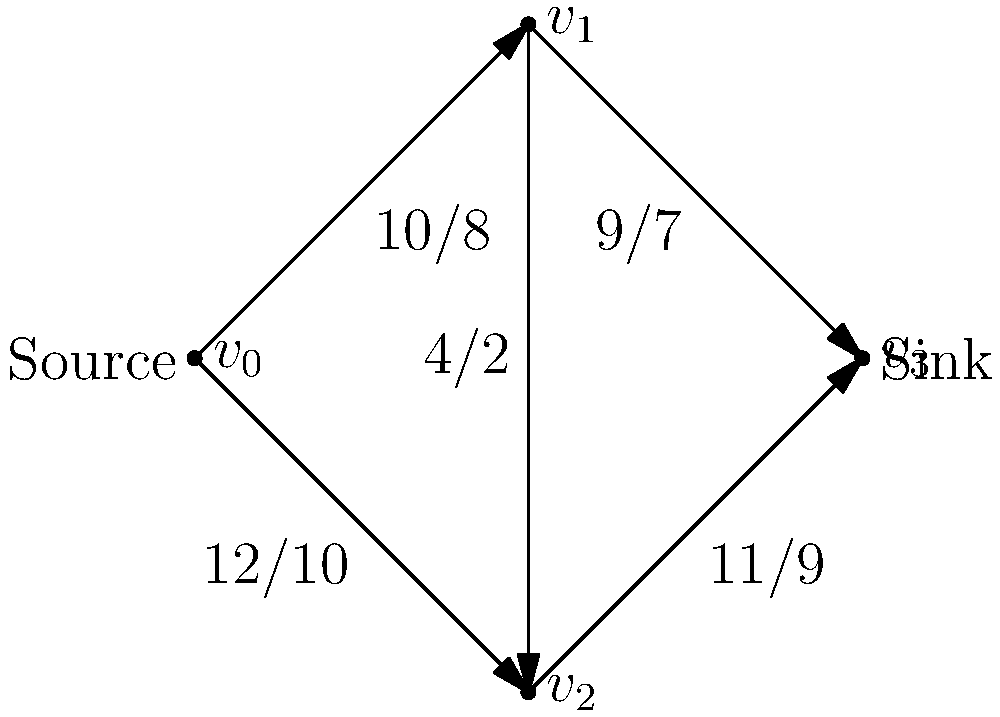In the given flow network representing a chemical production process, where edges show capacity/flow, what is the maximum amount of additional flow that can be pushed from the source to the sink to minimize waste in the production process? To find the maximum additional flow, we need to follow these steps:

1. Identify the current flow in the network:
   - $v_0 \to v_1$: 8
   - $v_0 \to v_2$: 10
   - $v_1 \to v_3$: 7
   - $v_2 \to v_3$: 9
   - $v_1 \to v_2$: 2

2. Calculate the residual capacities for each edge:
   - $v_0 \to v_1$: 10 - 8 = 2
   - $v_0 \to v_2$: 12 - 10 = 2
   - $v_1 \to v_3$: 9 - 7 = 2
   - $v_2 \to v_3$: 11 - 9 = 2
   - $v_1 \to v_2$: 4 - 2 = 2
   - $v_2 \to v_1$: 2 (reverse edge)

3. Find augmenting paths in the residual network:
   Path 1: $v_0 \to v_1 \to v_3$ (min capacity = 2)
   Path 2: $v_0 \to v_2 \to v_3$ (min capacity = 2)

4. The maximum additional flow is the sum of the minimum capacities of these augmenting paths:
   Maximum additional flow = 2 + 2 = 4

Therefore, an additional 4 units of flow can be pushed from the source to the sink to minimize waste in the production process.
Answer: 4 units 